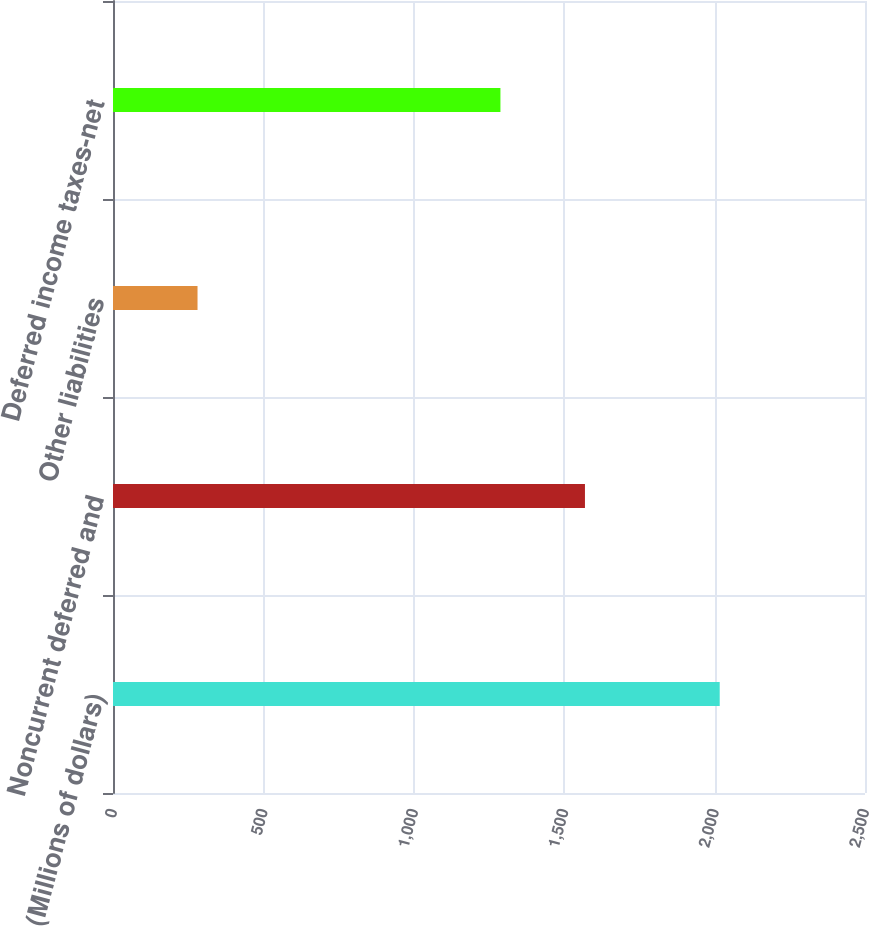Convert chart to OTSL. <chart><loc_0><loc_0><loc_500><loc_500><bar_chart><fcel>(Millions of dollars)<fcel>Noncurrent deferred and<fcel>Other liabilities<fcel>Deferred income taxes-net<nl><fcel>2017<fcel>1569<fcel>281<fcel>1288<nl></chart> 